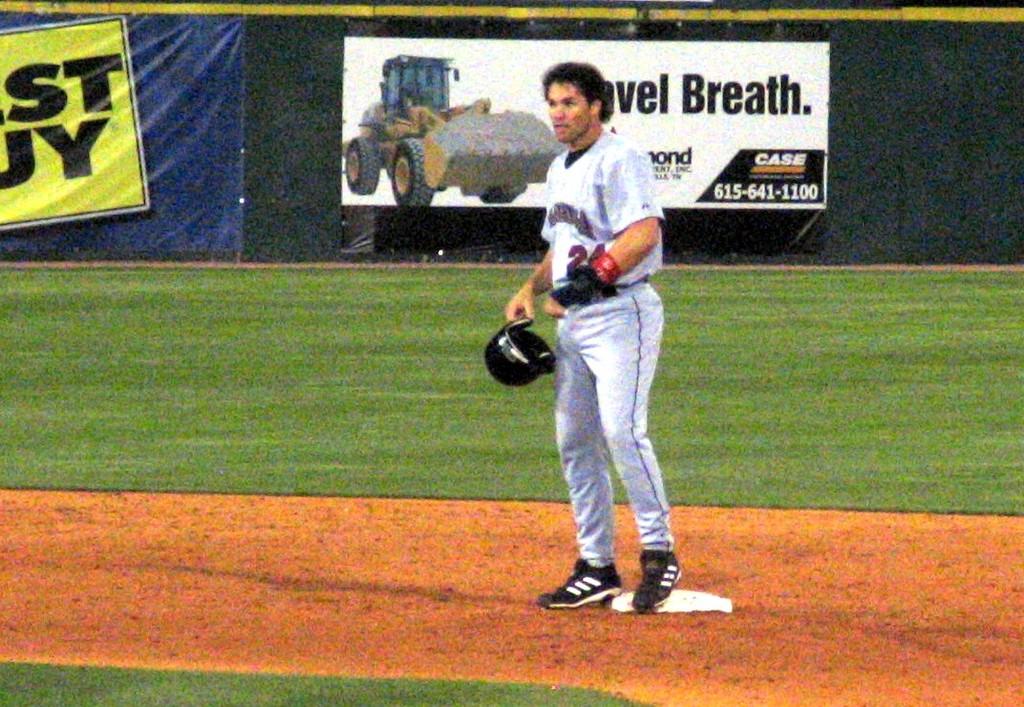What is the phone number on the white banner?
Your response must be concise. 615-641-1100. What brand is the tractor?
Make the answer very short. Case. 